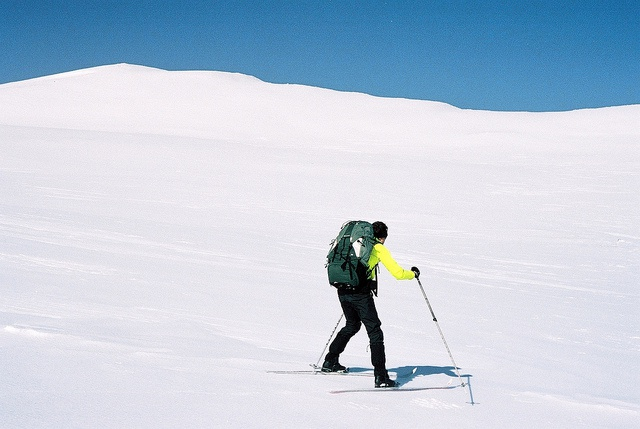Describe the objects in this image and their specific colors. I can see people in teal, black, lightgray, and gray tones, backpack in teal, black, and white tones, and skis in teal, lightgray, darkgray, and gray tones in this image. 